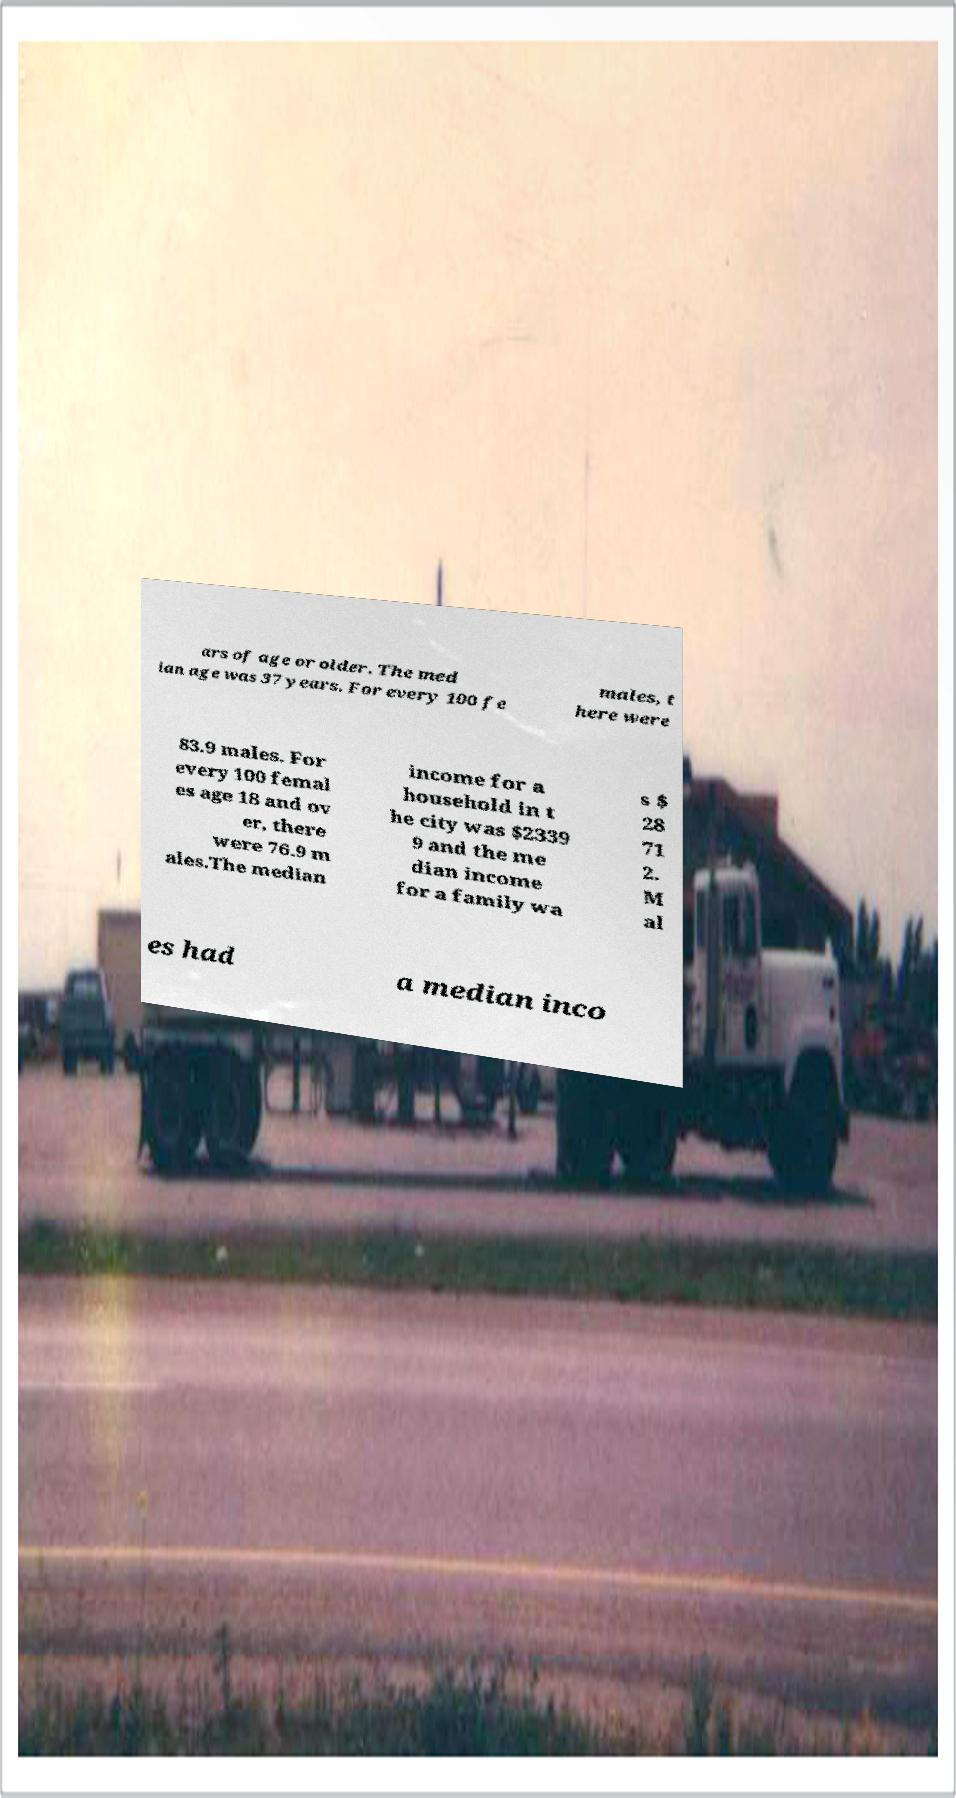Can you read and provide the text displayed in the image?This photo seems to have some interesting text. Can you extract and type it out for me? ars of age or older. The med ian age was 37 years. For every 100 fe males, t here were 83.9 males. For every 100 femal es age 18 and ov er, there were 76.9 m ales.The median income for a household in t he city was $2339 9 and the me dian income for a family wa s $ 28 71 2. M al es had a median inco 